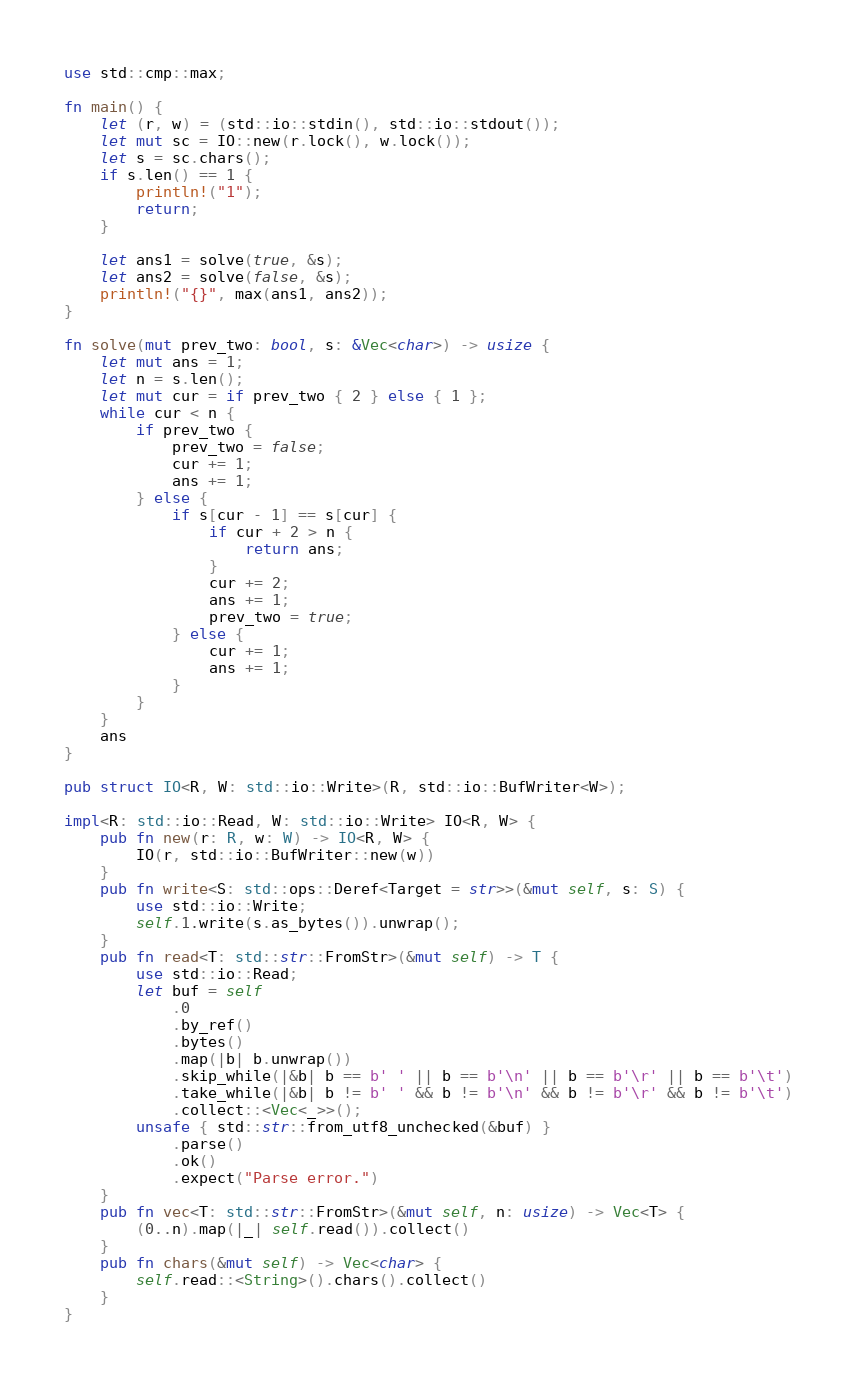Convert code to text. <code><loc_0><loc_0><loc_500><loc_500><_Rust_>use std::cmp::max;

fn main() {
    let (r, w) = (std::io::stdin(), std::io::stdout());
    let mut sc = IO::new(r.lock(), w.lock());
    let s = sc.chars();
    if s.len() == 1 {
        println!("1");
        return;
    }

    let ans1 = solve(true, &s);
    let ans2 = solve(false, &s);
    println!("{}", max(ans1, ans2));
}

fn solve(mut prev_two: bool, s: &Vec<char>) -> usize {
    let mut ans = 1;
    let n = s.len();
    let mut cur = if prev_two { 2 } else { 1 };
    while cur < n {
        if prev_two {
            prev_two = false;
            cur += 1;
            ans += 1;
        } else {
            if s[cur - 1] == s[cur] {
                if cur + 2 > n {
                    return ans;
                }
                cur += 2;
                ans += 1;
                prev_two = true;
            } else {
                cur += 1;
                ans += 1;
            }
        }
    }
    ans
}

pub struct IO<R, W: std::io::Write>(R, std::io::BufWriter<W>);

impl<R: std::io::Read, W: std::io::Write> IO<R, W> {
    pub fn new(r: R, w: W) -> IO<R, W> {
        IO(r, std::io::BufWriter::new(w))
    }
    pub fn write<S: std::ops::Deref<Target = str>>(&mut self, s: S) {
        use std::io::Write;
        self.1.write(s.as_bytes()).unwrap();
    }
    pub fn read<T: std::str::FromStr>(&mut self) -> T {
        use std::io::Read;
        let buf = self
            .0
            .by_ref()
            .bytes()
            .map(|b| b.unwrap())
            .skip_while(|&b| b == b' ' || b == b'\n' || b == b'\r' || b == b'\t')
            .take_while(|&b| b != b' ' && b != b'\n' && b != b'\r' && b != b'\t')
            .collect::<Vec<_>>();
        unsafe { std::str::from_utf8_unchecked(&buf) }
            .parse()
            .ok()
            .expect("Parse error.")
    }
    pub fn vec<T: std::str::FromStr>(&mut self, n: usize) -> Vec<T> {
        (0..n).map(|_| self.read()).collect()
    }
    pub fn chars(&mut self) -> Vec<char> {
        self.read::<String>().chars().collect()
    }
}
</code> 